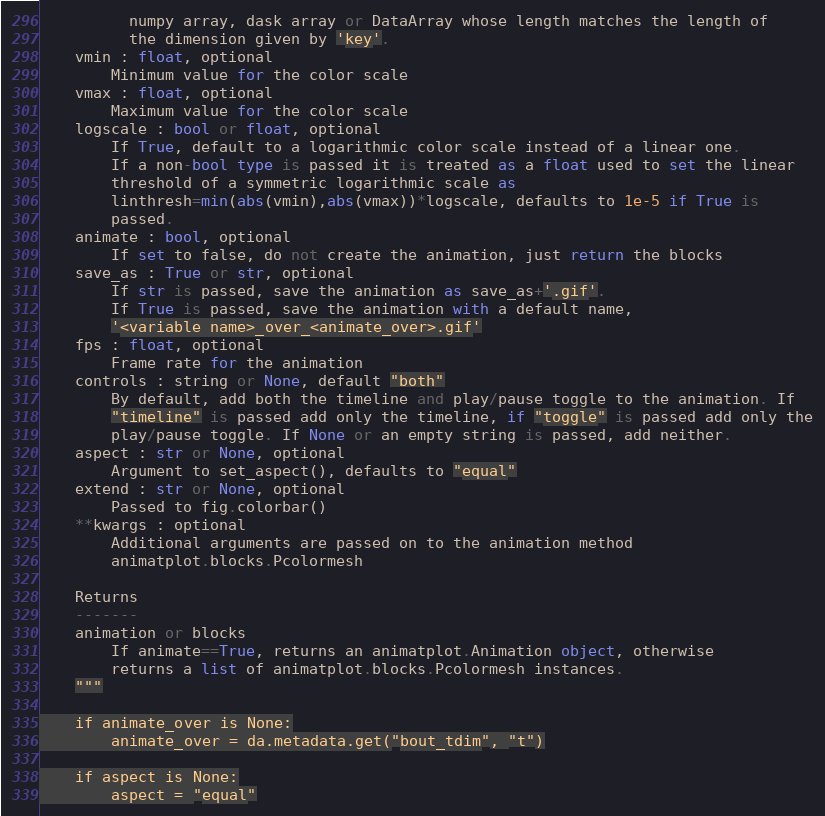<code> <loc_0><loc_0><loc_500><loc_500><_Python_>          numpy array, dask array or DataArray whose length matches the length of
          the dimension given by 'key'.
    vmin : float, optional
        Minimum value for the color scale
    vmax : float, optional
        Maximum value for the color scale
    logscale : bool or float, optional
        If True, default to a logarithmic color scale instead of a linear one.
        If a non-bool type is passed it is treated as a float used to set the linear
        threshold of a symmetric logarithmic scale as
        linthresh=min(abs(vmin),abs(vmax))*logscale, defaults to 1e-5 if True is
        passed.
    animate : bool, optional
        If set to false, do not create the animation, just return the blocks
    save_as : True or str, optional
        If str is passed, save the animation as save_as+'.gif'.
        If True is passed, save the animation with a default name,
        '<variable name>_over_<animate_over>.gif'
    fps : float, optional
        Frame rate for the animation
    controls : string or None, default "both"
        By default, add both the timeline and play/pause toggle to the animation. If
        "timeline" is passed add only the timeline, if "toggle" is passed add only the
        play/pause toggle. If None or an empty string is passed, add neither.
    aspect : str or None, optional
        Argument to set_aspect(), defaults to "equal"
    extend : str or None, optional
        Passed to fig.colorbar()
    **kwargs : optional
        Additional arguments are passed on to the animation method
        animatplot.blocks.Pcolormesh

    Returns
    -------
    animation or blocks
        If animate==True, returns an animatplot.Animation object, otherwise
        returns a list of animatplot.blocks.Pcolormesh instances.
    """

    if animate_over is None:
        animate_over = da.metadata.get("bout_tdim", "t")

    if aspect is None:
        aspect = "equal"
</code> 